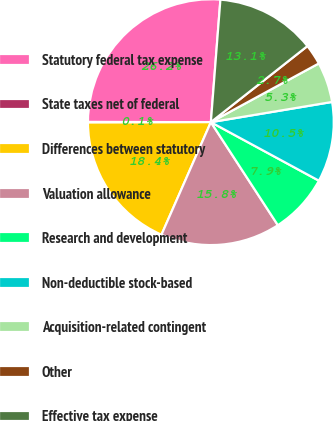Convert chart to OTSL. <chart><loc_0><loc_0><loc_500><loc_500><pie_chart><fcel>Statutory federal tax expense<fcel>State taxes net of federal<fcel>Differences between statutory<fcel>Valuation allowance<fcel>Research and development<fcel>Non-deductible stock-based<fcel>Acquisition-related contingent<fcel>Other<fcel>Effective tax expense<nl><fcel>26.21%<fcel>0.07%<fcel>18.37%<fcel>15.76%<fcel>7.92%<fcel>10.53%<fcel>5.3%<fcel>2.69%<fcel>13.14%<nl></chart> 